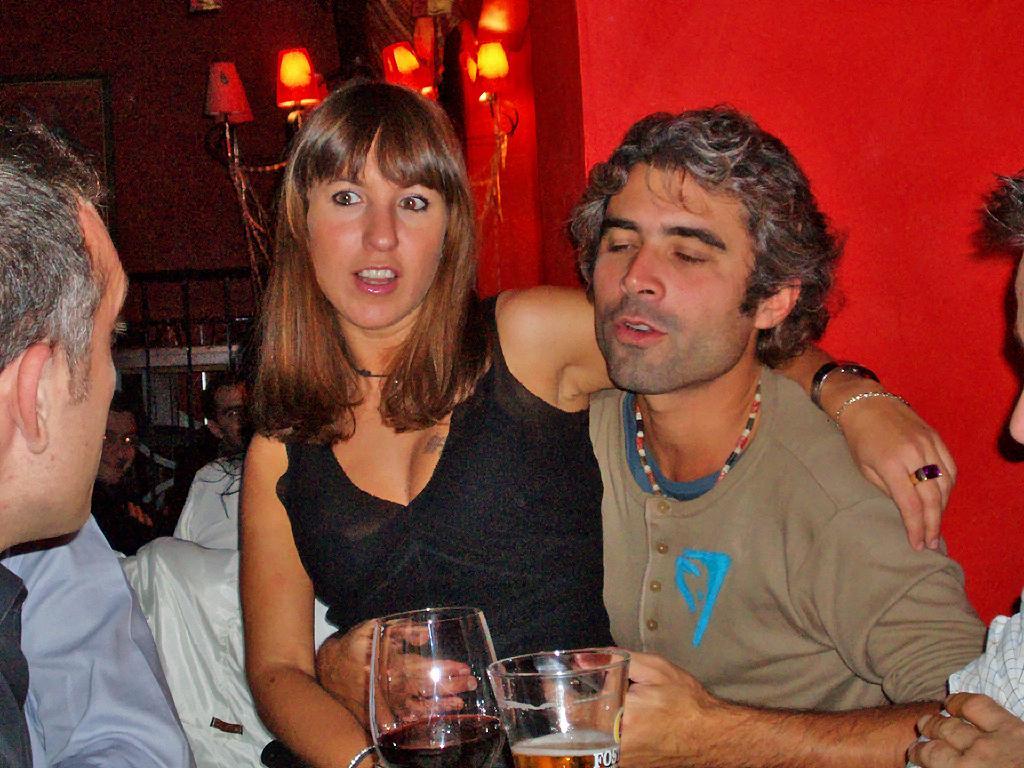Can you describe this image briefly? On the background we can see wall, lights. Here we can see person sitting. We can see this woman and a man holding drinking glasses in their hands. 